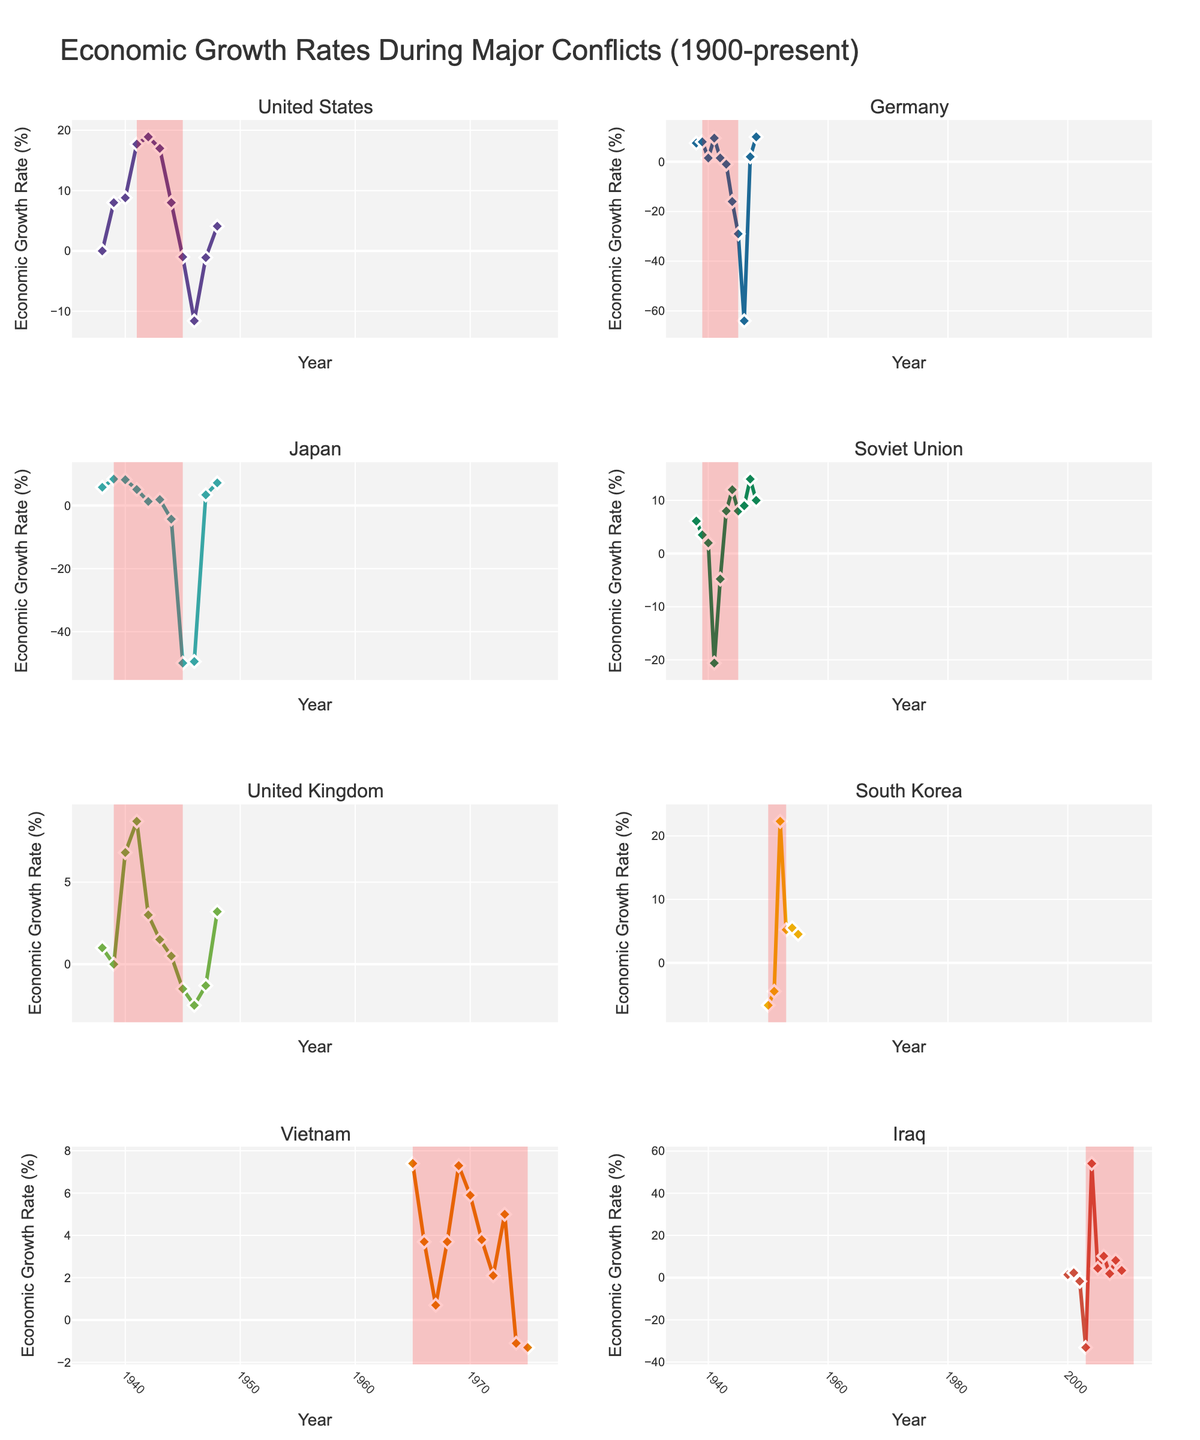What was the economic growth rate of the United States during the year 1945? To find the economic growth rate of the United States during the year 1945, identify the relevant data point for the year 1945 in the subplot for the United States.
Answer: -1.0% Which country experienced the most significant economic decline during the war period highlighted in red? Compare the economic growth rates during the highlighted war periods across all the countries. Germany's growth rate in 1946 was -64.0%, Japan's in 1945 was -50.0%, and the Soviet Union in 1941 was -20.6%. Germany had the most significant decline with -64.0%.
Answer: Germany How did the economic growth rates of Germany and Japan compare in 1948? Locate the economic growth rates for Germany and Japan for the year 1948 in their respective subplots. Germany's rate was 10.0%, while Japan's rate was 7.2%.
Answer: Germany's rate was higher (10.0% vs. 7.2%) What's the average economic growth rate of Japan from 1942 to 1944 inclusive? Calculate the sum of Japan's economic growth rates for the years 1942 (1.3), 1943 (1.9), and 1944 (-4.3), which equals (1.3 + 1.9 - 4.3) = -1.1. Then, divide by the number of years (3) to get the average.
Answer: (-1.1/3) ≈ -0.37% Between which years did South Korea experience an economic growth rate improvement after a decline due to war? Analyze the subplot for South Korea. The economic growth rate was -6.7% in 1950 and -4.5% in 1951, and then improved to 22.3% in 1952.
Answer: Between 1951 and 1952 Which year showed the highest economic growth rate for the Soviet Union, and what was the value? Examine the subplot for the Soviet Union and identify the peak economic growth rate. The highest rate was in 1947 with 14.0%.
Answer: 1947, 14.0% What was the net change in Iraq's economic growth rate from 2003 to 2004? Identify Iraq's economic growth rates for the years 2003 (-33.1%) and 2004 (54.1%). Calculate the difference: 54.1 - (-33.1) = 54.1 + 33.1 = 87.2.
Answer: 87.2% 